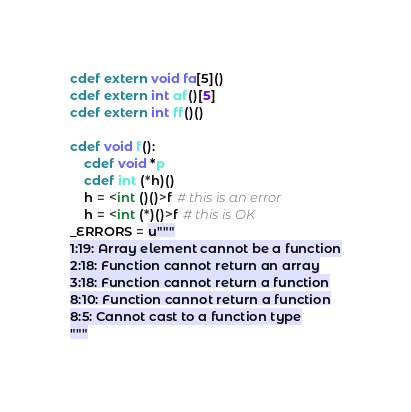Convert code to text. <code><loc_0><loc_0><loc_500><loc_500><_Cython_>cdef extern void fa[5]()
cdef extern int af()[5]
cdef extern int ff()()

cdef void f():
	cdef void *p
	cdef int (*h)()
	h = <int ()()>f # this is an error
	h = <int (*)()>f # this is OK
_ERRORS = u"""
1:19: Array element cannot be a function
2:18: Function cannot return an array
3:18: Function cannot return a function
8:10: Function cannot return a function
8:5: Cannot cast to a function type
"""
</code> 